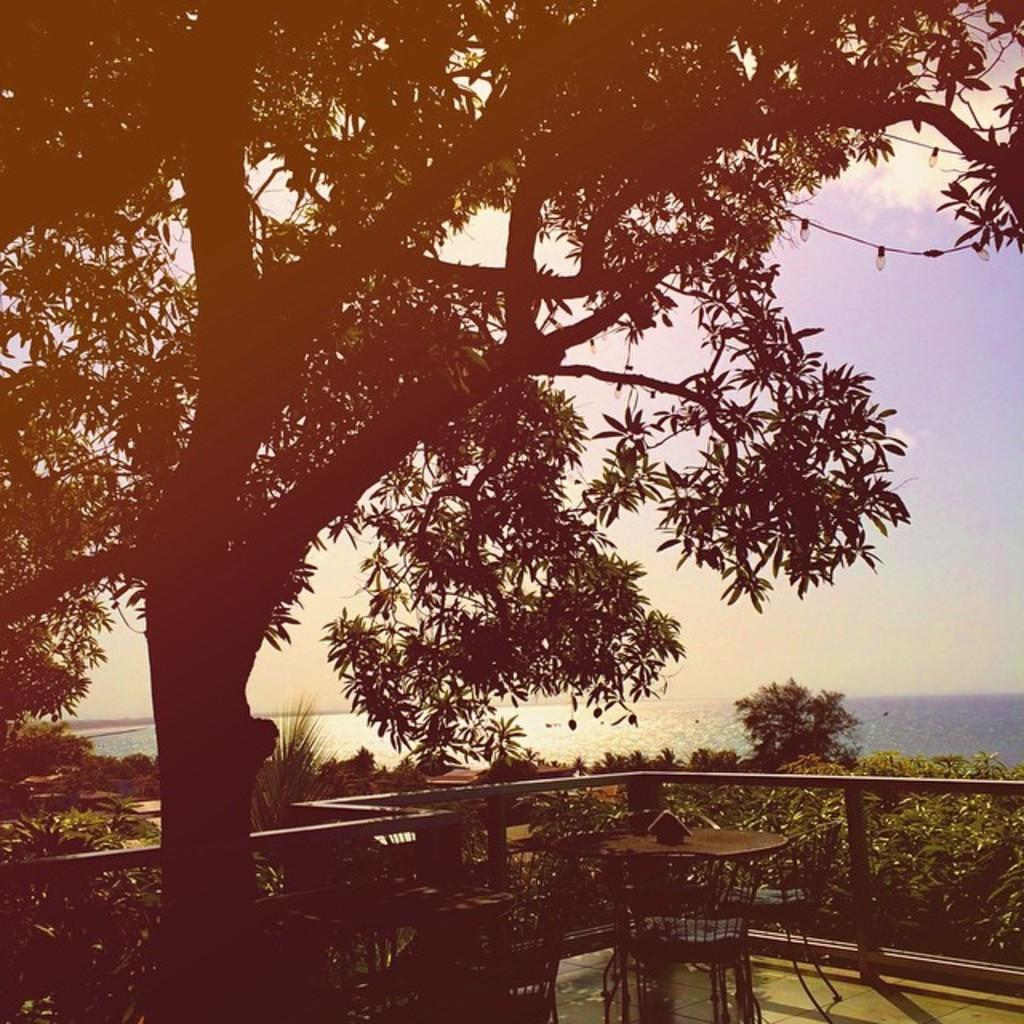What type of table is in the image? There is an iron table in the image. What other furniture is present in the image? There are iron chairs in the image. What is located in the front of the image? There is a huge tree in the front of the image. What can be seen in the background of the image? Trees and sea water are visible in the background of the image. What is visible above the scene in the image? The sky is visible in the image, and clouds are present in the sky. What type of treatment is being administered to the tree in the image? There is no treatment being administered to the tree in the image; it is a natural part of the scene. Is there a spy observing the scene from a hidden location in the image? There is no indication of a spy or any hidden location in the image. 